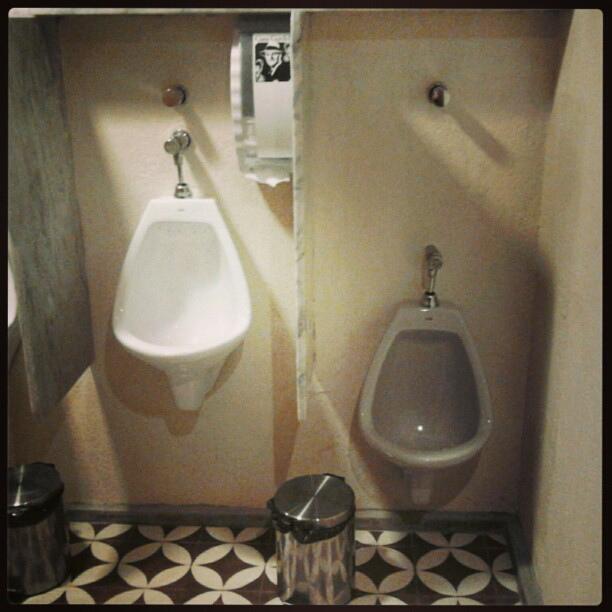Is there any doors in the image?
Concise answer only. No. What room is this?
Be succinct. Bathroom. How many urinals are there?
Keep it brief. 2. 